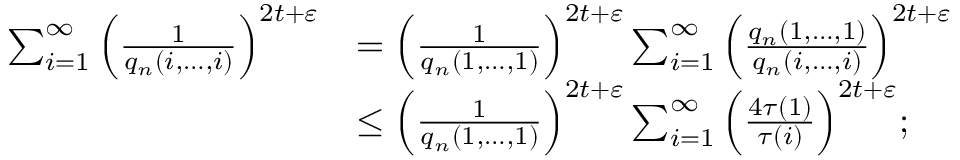Convert formula to latex. <formula><loc_0><loc_0><loc_500><loc_500>\begin{array} { r l } { \sum _ { i = 1 } ^ { \infty } \left ( \frac { 1 } { q _ { n } ( i , \dots , i ) } \right ) ^ { 2 t + \varepsilon } } & { = \left ( \frac { 1 } { q _ { n } ( 1 , \dots , 1 ) } \right ) ^ { 2 t + \varepsilon } \sum _ { i = 1 } ^ { \infty } \left ( \frac { q _ { n } ( 1 , \dots , 1 ) } { q _ { n } ( i , \dots , i ) } \right ) ^ { 2 t + \varepsilon } } \\ & { \leq \left ( \frac { 1 } { q _ { n } ( 1 , \dots , 1 ) } \right ) ^ { 2 t + \varepsilon } \sum _ { i = 1 } ^ { \infty } \left ( \frac { 4 \tau ( 1 ) } { \tau ( i ) } \right ) ^ { 2 t + \varepsilon } ; } \end{array}</formula> 